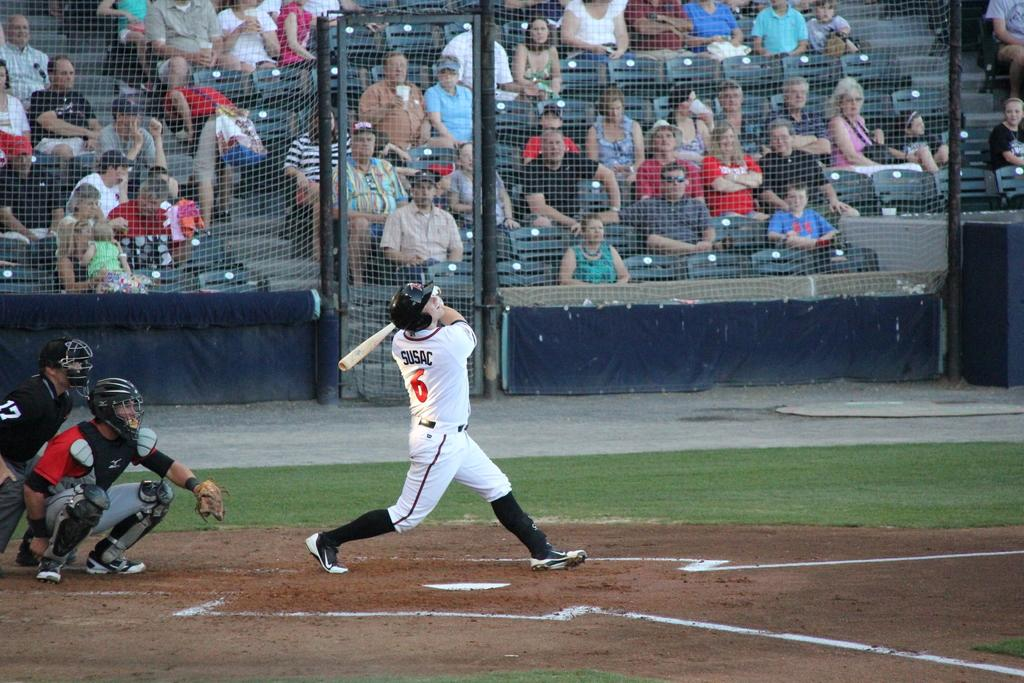<image>
Offer a succinct explanation of the picture presented. A player named Susac takes a mighty swing at the ball. 